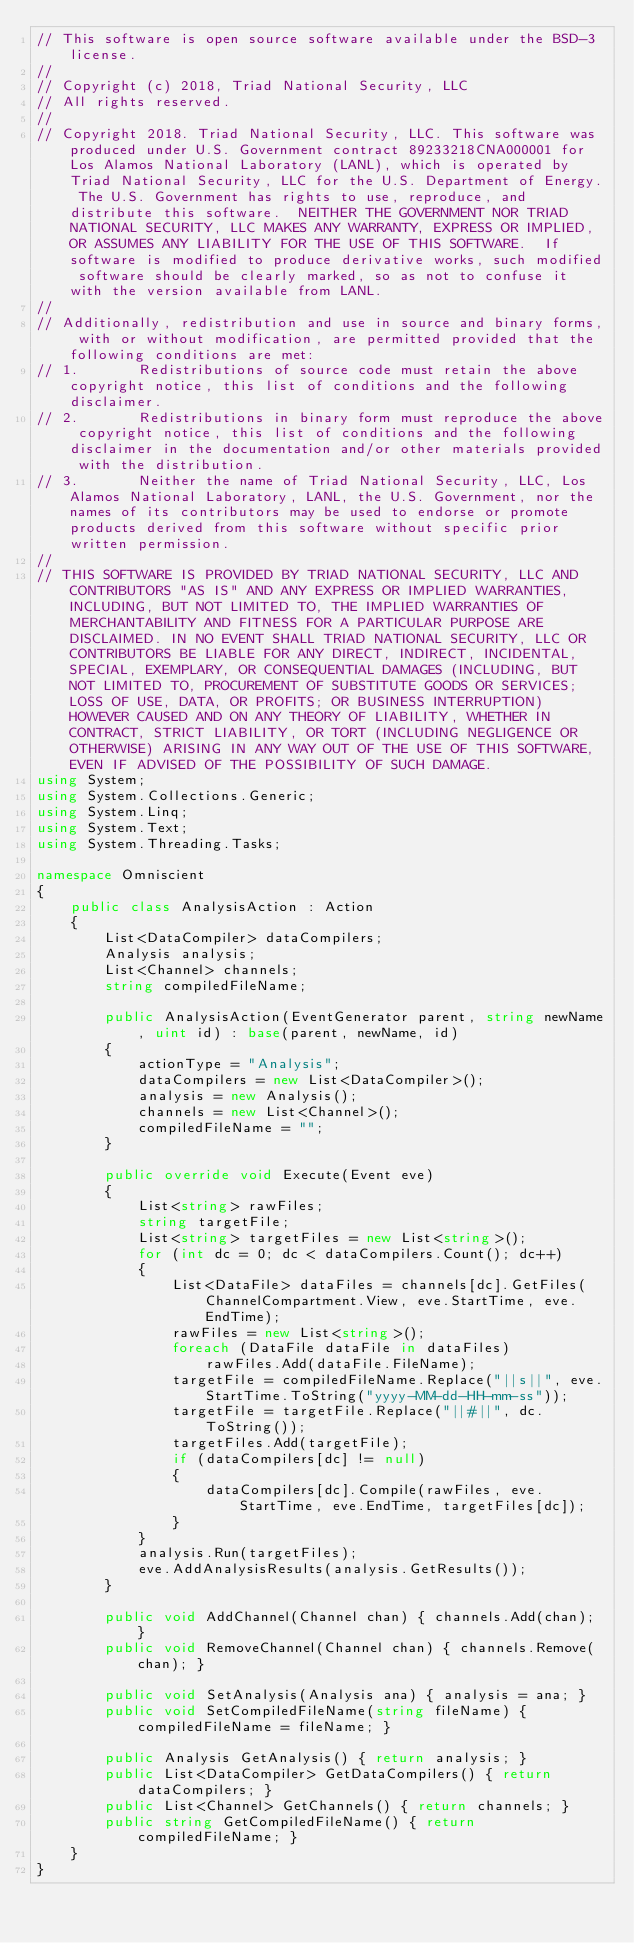<code> <loc_0><loc_0><loc_500><loc_500><_C#_>// This software is open source software available under the BSD-3 license.
// 
// Copyright (c) 2018, Triad National Security, LLC
// All rights reserved.
// 
// Copyright 2018. Triad National Security, LLC. This software was produced under U.S. Government contract 89233218CNA000001 for Los Alamos National Laboratory (LANL), which is operated by Triad National Security, LLC for the U.S. Department of Energy. The U.S. Government has rights to use, reproduce, and distribute this software.  NEITHER THE GOVERNMENT NOR TRIAD NATIONAL SECURITY, LLC MAKES ANY WARRANTY, EXPRESS OR IMPLIED, OR ASSUMES ANY LIABILITY FOR THE USE OF THIS SOFTWARE.  If software is modified to produce derivative works, such modified software should be clearly marked, so as not to confuse it with the version available from LANL.
// 
// Additionally, redistribution and use in source and binary forms, with or without modification, are permitted provided that the following conditions are met:
// 1.       Redistributions of source code must retain the above copyright notice, this list of conditions and the following disclaimer. 
// 2.       Redistributions in binary form must reproduce the above copyright notice, this list of conditions and the following disclaimer in the documentation and/or other materials provided with the distribution. 
// 3.       Neither the name of Triad National Security, LLC, Los Alamos National Laboratory, LANL, the U.S. Government, nor the names of its contributors may be used to endorse or promote products derived from this software without specific prior written permission. 
//  
// THIS SOFTWARE IS PROVIDED BY TRIAD NATIONAL SECURITY, LLC AND CONTRIBUTORS "AS IS" AND ANY EXPRESS OR IMPLIED WARRANTIES, INCLUDING, BUT NOT LIMITED TO, THE IMPLIED WARRANTIES OF MERCHANTABILITY AND FITNESS FOR A PARTICULAR PURPOSE ARE DISCLAIMED. IN NO EVENT SHALL TRIAD NATIONAL SECURITY, LLC OR CONTRIBUTORS BE LIABLE FOR ANY DIRECT, INDIRECT, INCIDENTAL, SPECIAL, EXEMPLARY, OR CONSEQUENTIAL DAMAGES (INCLUDING, BUT NOT LIMITED TO, PROCUREMENT OF SUBSTITUTE GOODS OR SERVICES; LOSS OF USE, DATA, OR PROFITS; OR BUSINESS INTERRUPTION) HOWEVER CAUSED AND ON ANY THEORY OF LIABILITY, WHETHER IN CONTRACT, STRICT LIABILITY, OR TORT (INCLUDING NEGLIGENCE OR OTHERWISE) ARISING IN ANY WAY OUT OF THE USE OF THIS SOFTWARE, EVEN IF ADVISED OF THE POSSIBILITY OF SUCH DAMAGE.
using System;
using System.Collections.Generic;
using System.Linq;
using System.Text;
using System.Threading.Tasks;

namespace Omniscient
{
    public class AnalysisAction : Action
    {
        List<DataCompiler> dataCompilers;
        Analysis analysis;
        List<Channel> channels;
        string compiledFileName;

        public AnalysisAction(EventGenerator parent, string newName, uint id) : base(parent, newName, id)
        {
            actionType = "Analysis";
            dataCompilers = new List<DataCompiler>();
            analysis = new Analysis();
            channels = new List<Channel>();
            compiledFileName = "";
        }

        public override void Execute(Event eve)
        {
            List<string> rawFiles;
            string targetFile;
            List<string> targetFiles = new List<string>();
            for (int dc = 0; dc < dataCompilers.Count(); dc++)
            {
                List<DataFile> dataFiles = channels[dc].GetFiles(ChannelCompartment.View, eve.StartTime, eve.EndTime);
                rawFiles = new List<string>();
                foreach (DataFile dataFile in dataFiles)
                    rawFiles.Add(dataFile.FileName);
                targetFile = compiledFileName.Replace("||s||", eve.StartTime.ToString("yyyy-MM-dd-HH-mm-ss"));
                targetFile = targetFile.Replace("||#||", dc.ToString());
                targetFiles.Add(targetFile);
                if (dataCompilers[dc] != null)
                {
                    dataCompilers[dc].Compile(rawFiles, eve.StartTime, eve.EndTime, targetFiles[dc]);
                }
            }
            analysis.Run(targetFiles);
            eve.AddAnalysisResults(analysis.GetResults());
        }

        public void AddChannel(Channel chan) { channels.Add(chan); }
        public void RemoveChannel(Channel chan) { channels.Remove(chan); }

        public void SetAnalysis(Analysis ana) { analysis = ana; }
        public void SetCompiledFileName(string fileName) { compiledFileName = fileName; }

        public Analysis GetAnalysis() { return analysis; }
        public List<DataCompiler> GetDataCompilers() { return dataCompilers; }
        public List<Channel> GetChannels() { return channels; }
        public string GetCompiledFileName() { return compiledFileName; }
    }
}
</code> 